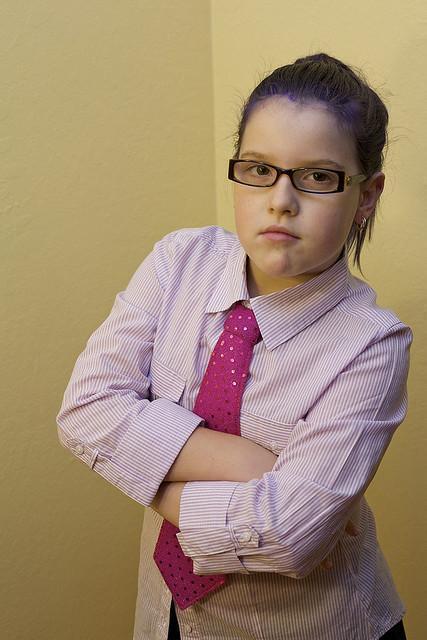How many dog can you see in the image?
Give a very brief answer. 0. 